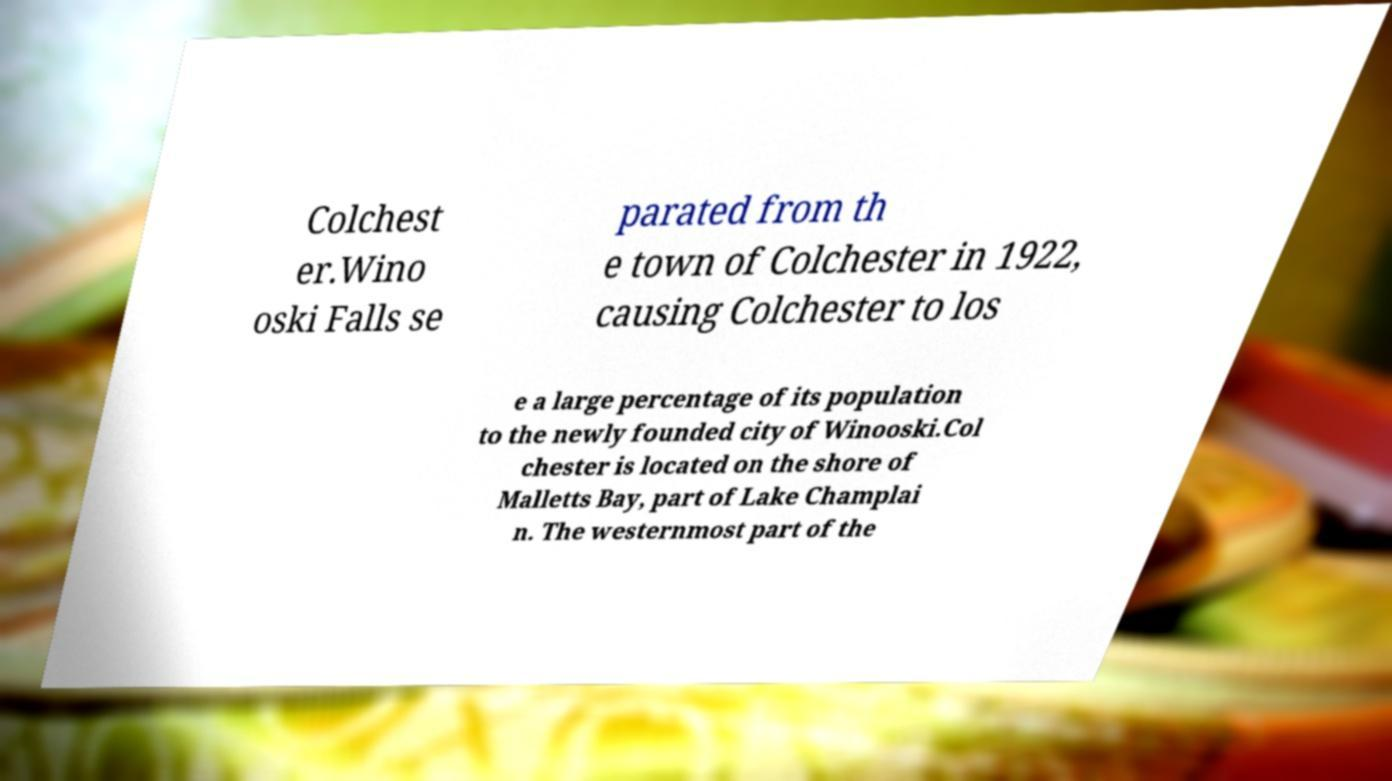Can you read and provide the text displayed in the image?This photo seems to have some interesting text. Can you extract and type it out for me? Colchest er.Wino oski Falls se parated from th e town of Colchester in 1922, causing Colchester to los e a large percentage of its population to the newly founded city of Winooski.Col chester is located on the shore of Malletts Bay, part of Lake Champlai n. The westernmost part of the 